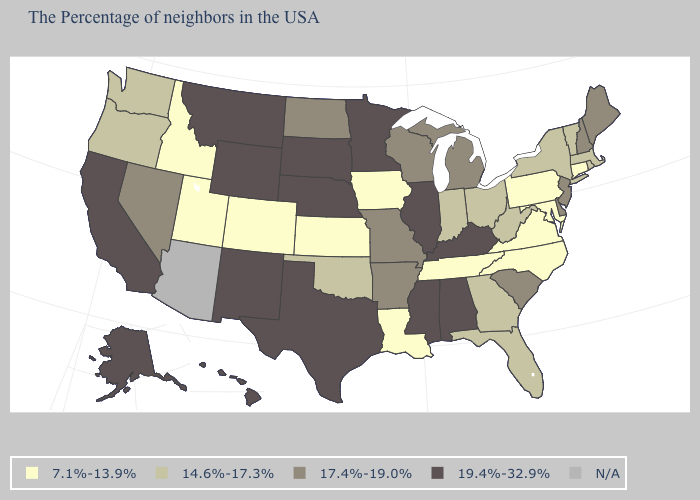Does Tennessee have the lowest value in the South?
Quick response, please. Yes. What is the value of New Hampshire?
Answer briefly. 17.4%-19.0%. What is the value of South Dakota?
Short answer required. 19.4%-32.9%. What is the value of Montana?
Give a very brief answer. 19.4%-32.9%. Name the states that have a value in the range 19.4%-32.9%?
Be succinct. Kentucky, Alabama, Illinois, Mississippi, Minnesota, Nebraska, Texas, South Dakota, Wyoming, New Mexico, Montana, California, Alaska, Hawaii. Name the states that have a value in the range 19.4%-32.9%?
Quick response, please. Kentucky, Alabama, Illinois, Mississippi, Minnesota, Nebraska, Texas, South Dakota, Wyoming, New Mexico, Montana, California, Alaska, Hawaii. What is the value of Indiana?
Write a very short answer. 14.6%-17.3%. Name the states that have a value in the range 14.6%-17.3%?
Quick response, please. Massachusetts, Rhode Island, Vermont, New York, West Virginia, Ohio, Florida, Georgia, Indiana, Oklahoma, Washington, Oregon. Among the states that border Ohio , which have the lowest value?
Short answer required. Pennsylvania. What is the value of Utah?
Write a very short answer. 7.1%-13.9%. Name the states that have a value in the range 7.1%-13.9%?
Concise answer only. Connecticut, Maryland, Pennsylvania, Virginia, North Carolina, Tennessee, Louisiana, Iowa, Kansas, Colorado, Utah, Idaho. Name the states that have a value in the range 7.1%-13.9%?
Short answer required. Connecticut, Maryland, Pennsylvania, Virginia, North Carolina, Tennessee, Louisiana, Iowa, Kansas, Colorado, Utah, Idaho. What is the lowest value in the South?
Keep it brief. 7.1%-13.9%. What is the highest value in states that border Tennessee?
Concise answer only. 19.4%-32.9%. 